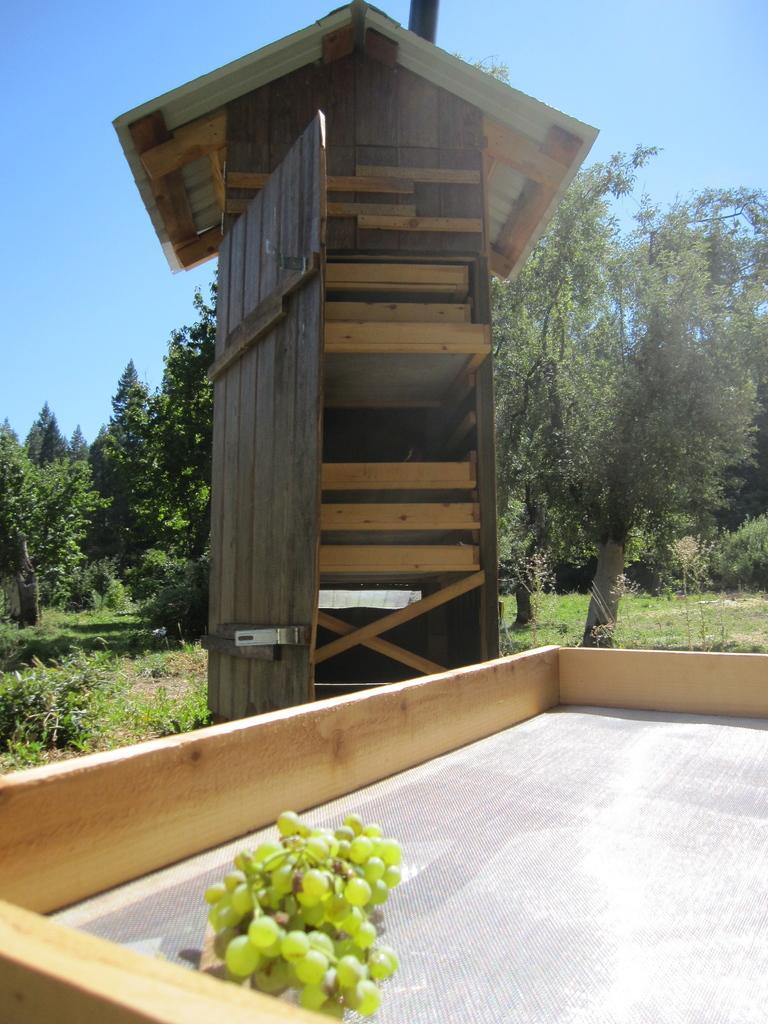What type of fruit can be seen in the image? There are there any grapes? What is the color and material of the tower in the image? The tower in the image is brown-colored and made of wood. What type of vegetation is present in the image? Trees and grass are present in the image. What can be seen in the background of the image? The sky is visible in the background of the image. Can you see any marbles rolling down the wooden tower in the image? There are no marbles present in the image, and the wooden tower is not depicted as having any marbles rolling down it. Is there a coast visible in the image? No, there is no coast visible in the image; it features a wooden tower, trees, grass, and grapes. 